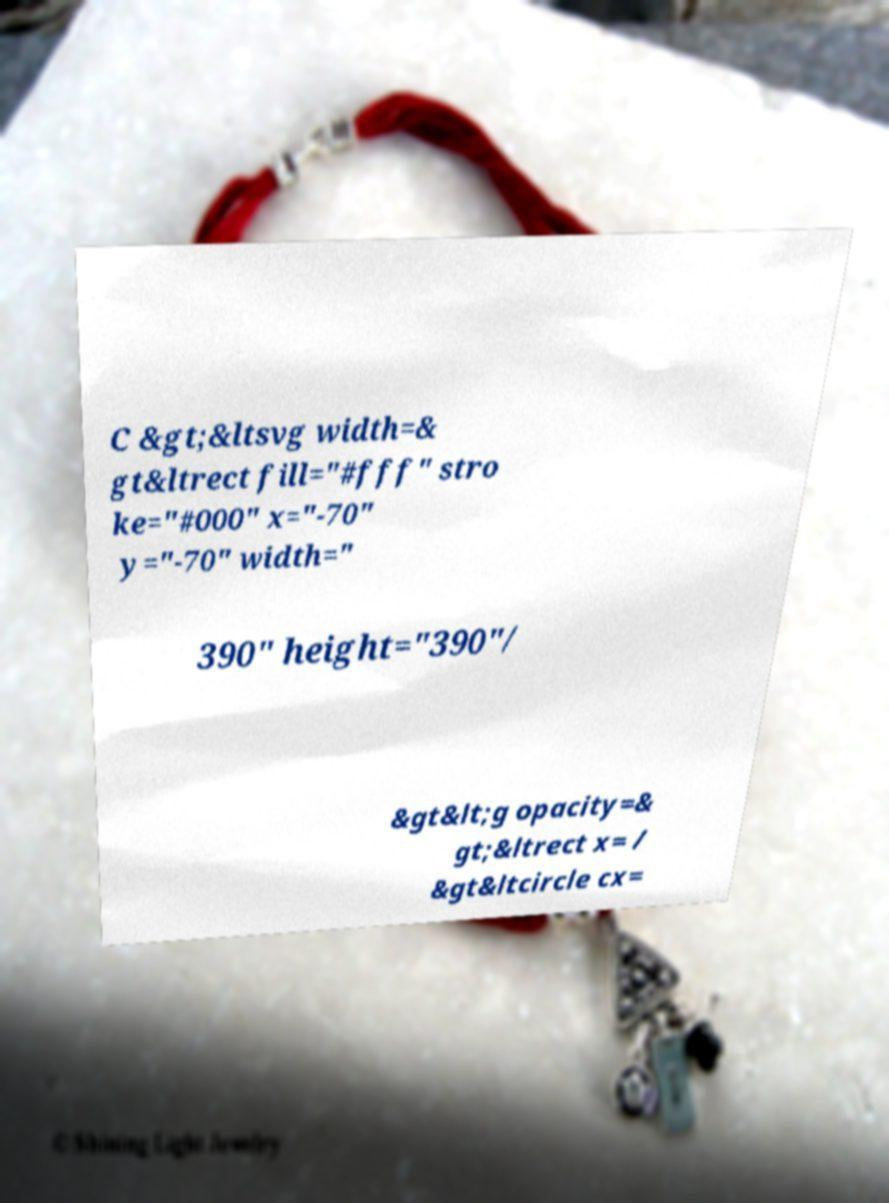Please identify and transcribe the text found in this image. C &gt;&ltsvg width=& gt&ltrect fill="#fff" stro ke="#000" x="-70" y="-70" width=" 390" height="390"/ &gt&lt;g opacity=& gt;&ltrect x= / &gt&ltcircle cx= 